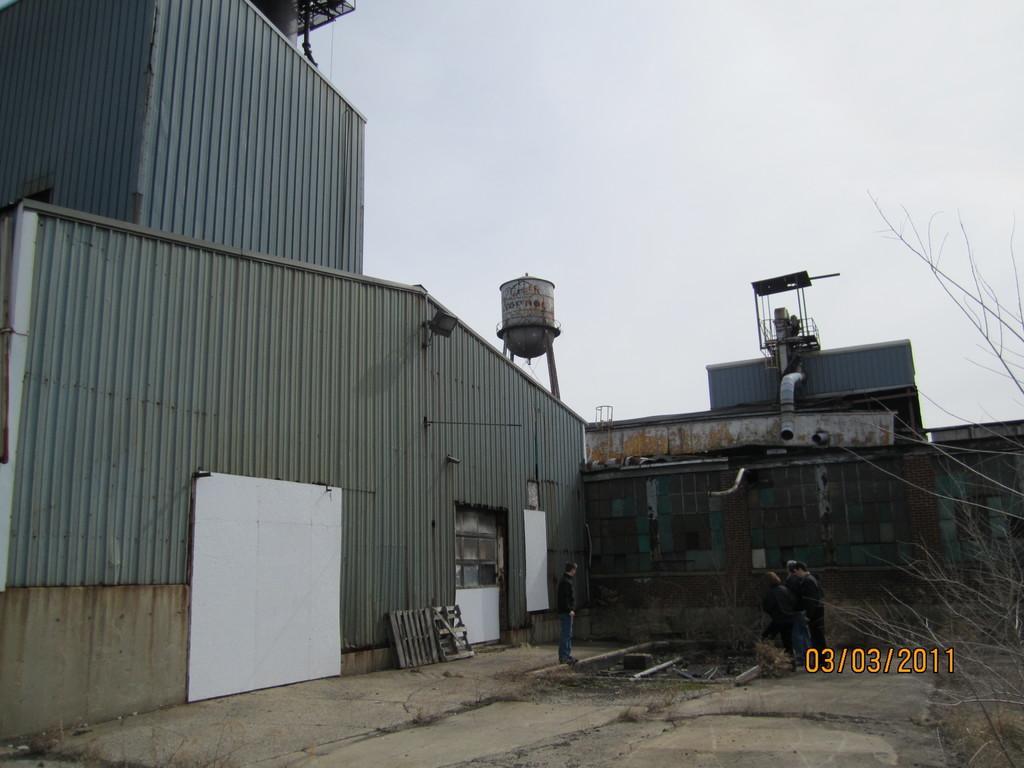In one or two sentences, can you explain what this image depicts? In this image there are some buildings, and at the bottom there is a walkway and on the right side there are some trees and there is a text. And in the center there are some persons standing, and also there are some boards. At the top there is sky, and in the center there are some other objects and a pipe. 